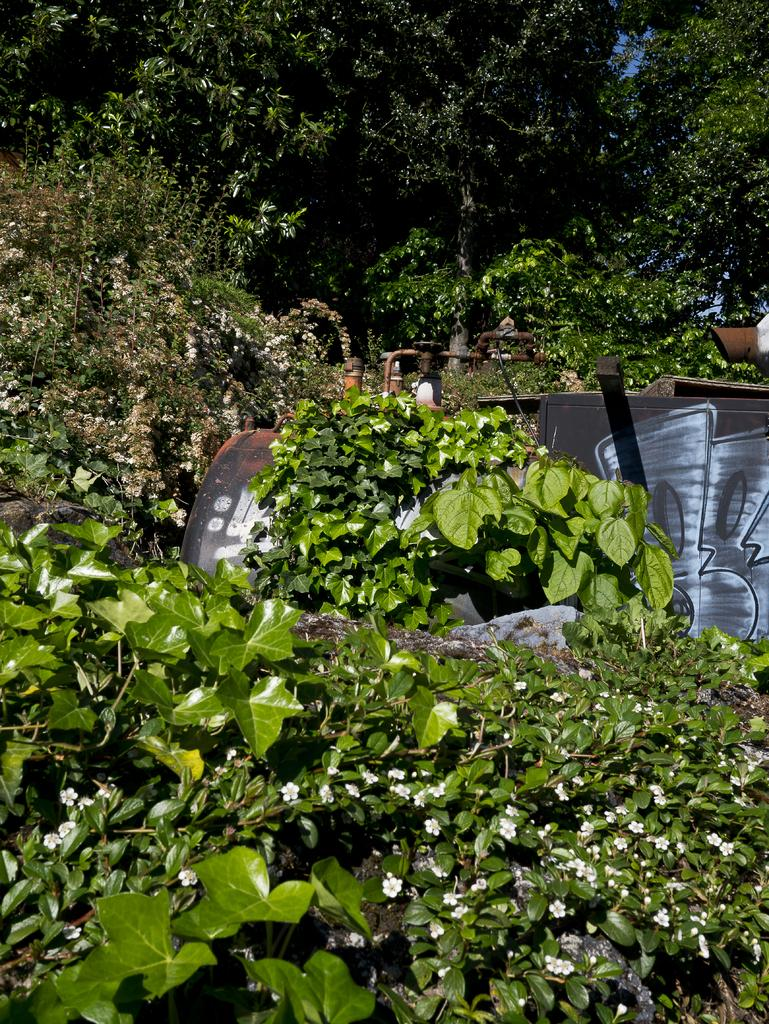What type of vegetation is present in the image? There are green leaves and trees in the image. Can you describe the color of the object in the image? The object in the image has a black and brown color. What type of paste can be seen on the leaves in the image? There is no paste present on the leaves in the image. What scent can be detected from the trees in the image? The image does not provide any information about the scent of the trees. 